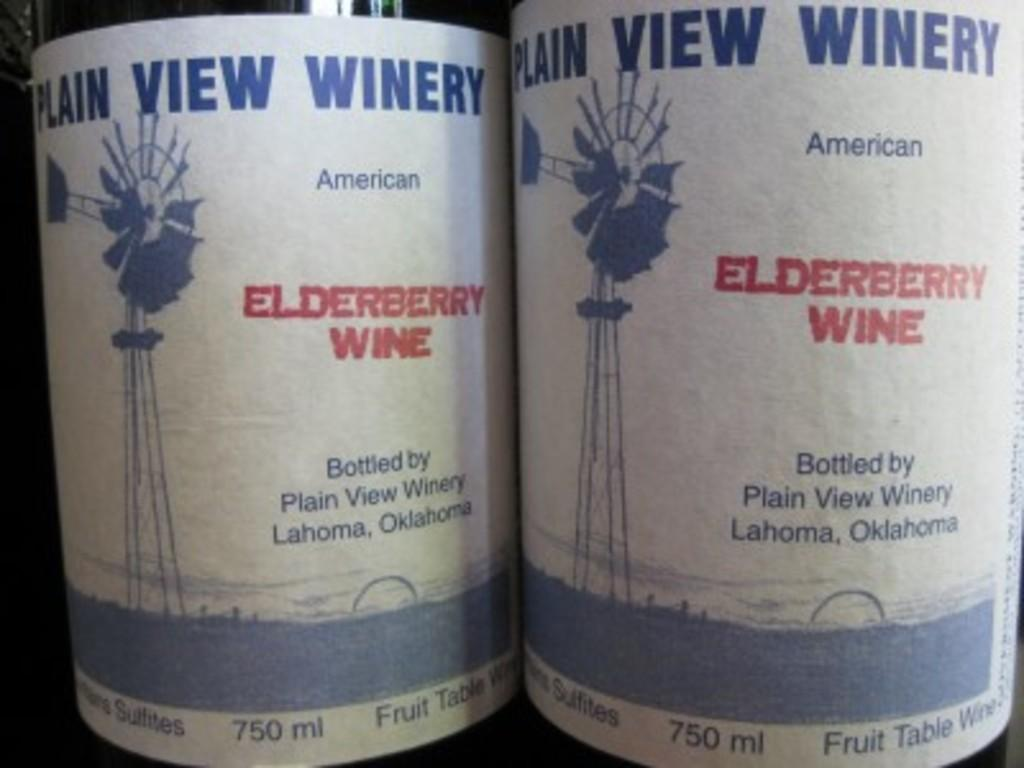<image>
Offer a succinct explanation of the picture presented. Two bottles of elderberry wine sit next to each other. 